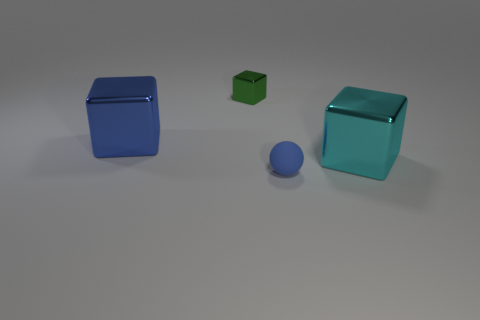Is the number of big cyan metallic cubes greater than the number of gray rubber spheres?
Your answer should be compact. Yes. What is the color of the big shiny object that is right of the green cube?
Ensure brevity in your answer.  Cyan. Is the number of objects that are on the left side of the blue shiny thing greater than the number of large yellow metal cylinders?
Your answer should be very brief. No. Is the material of the blue cube the same as the tiny blue sphere?
Provide a succinct answer. No. What number of other things are the same shape as the green shiny thing?
Give a very brief answer. 2. Are there any other things that have the same material as the big blue cube?
Offer a terse response. Yes. There is a large block on the left side of the cube that is in front of the large object left of the big cyan thing; what color is it?
Provide a short and direct response. Blue. Do the tiny object that is behind the small blue sphere and the small blue object have the same shape?
Make the answer very short. No. How many small gray blocks are there?
Your answer should be compact. 0. How many blue matte spheres are the same size as the green shiny block?
Make the answer very short. 1. 